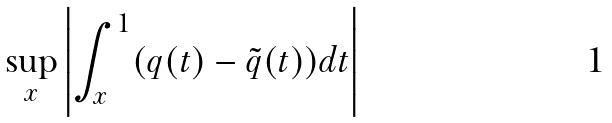<formula> <loc_0><loc_0><loc_500><loc_500>\sup _ { x } \left | \int _ { x } ^ { 1 } ( q ( t ) - \tilde { q } ( t ) ) d t \right |</formula> 